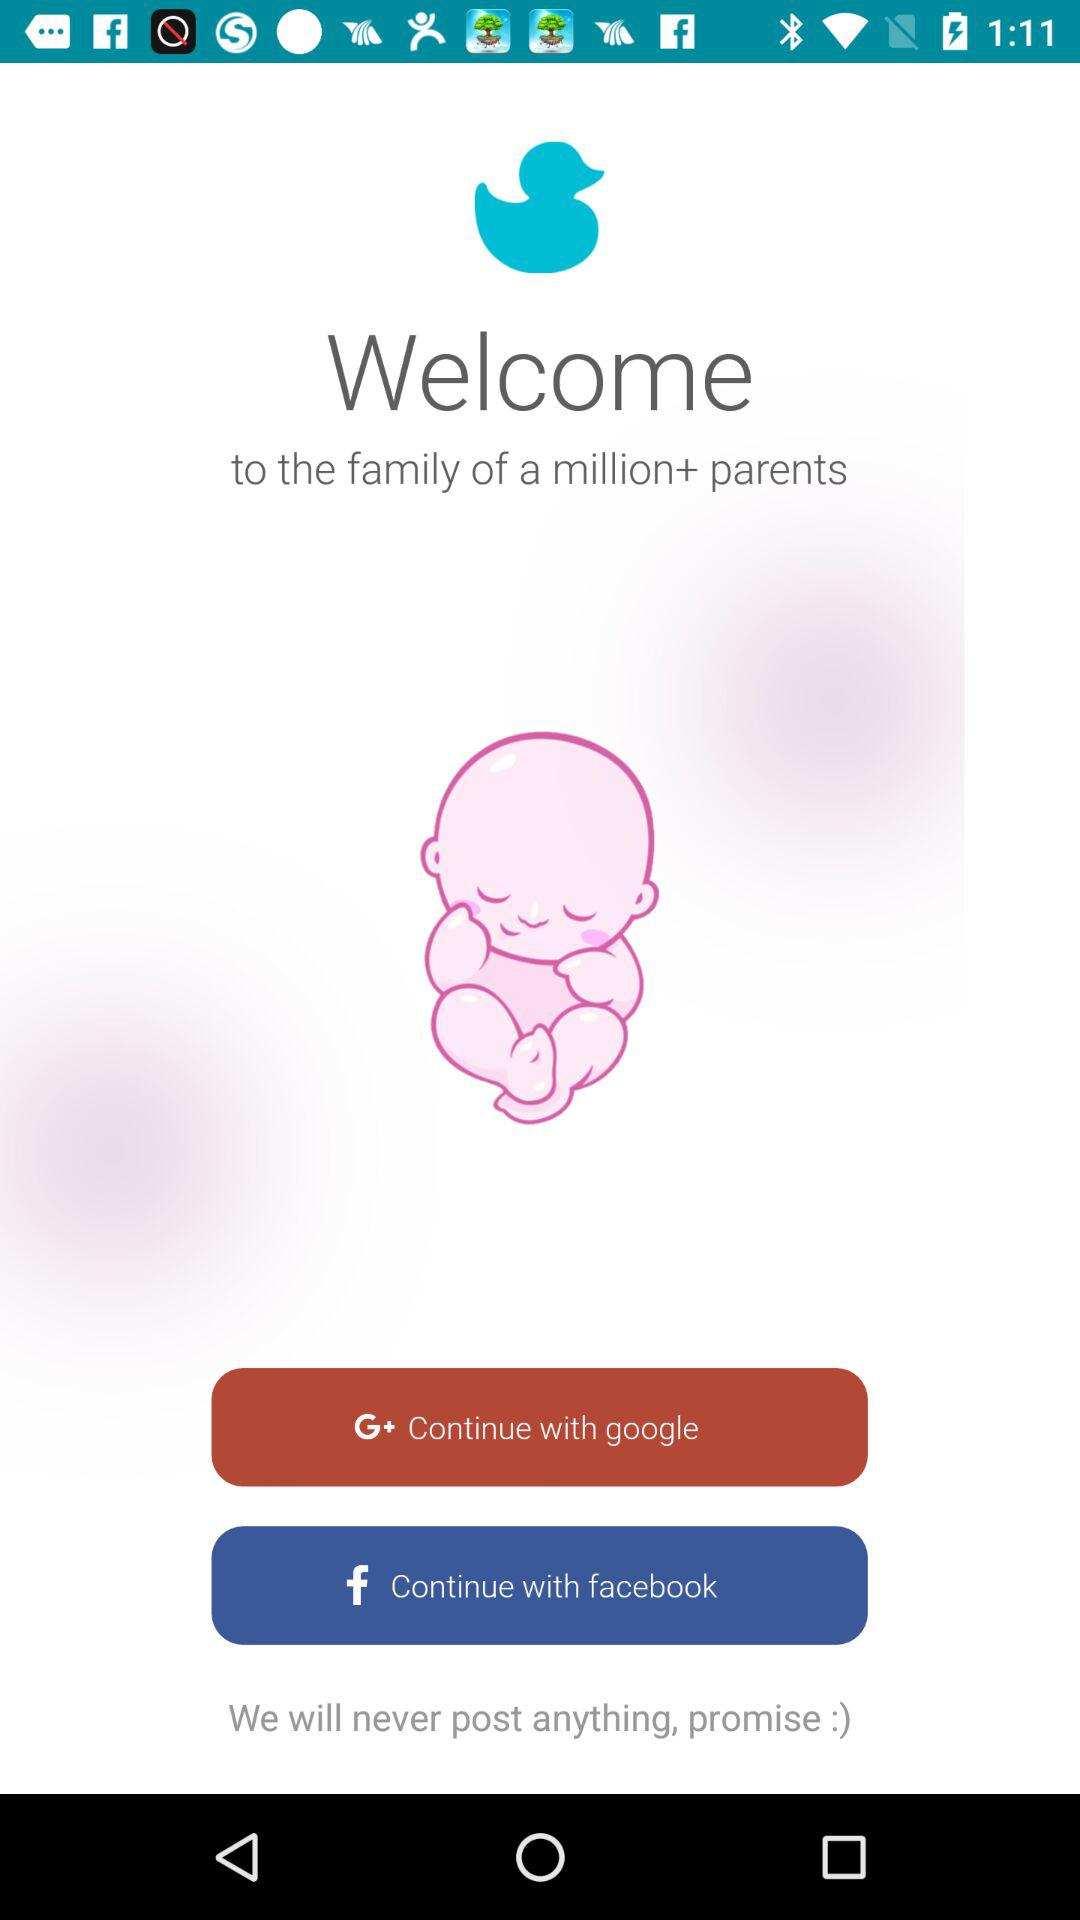Which options are given to continue with? The options given to continue with are "google" and "facebook". 